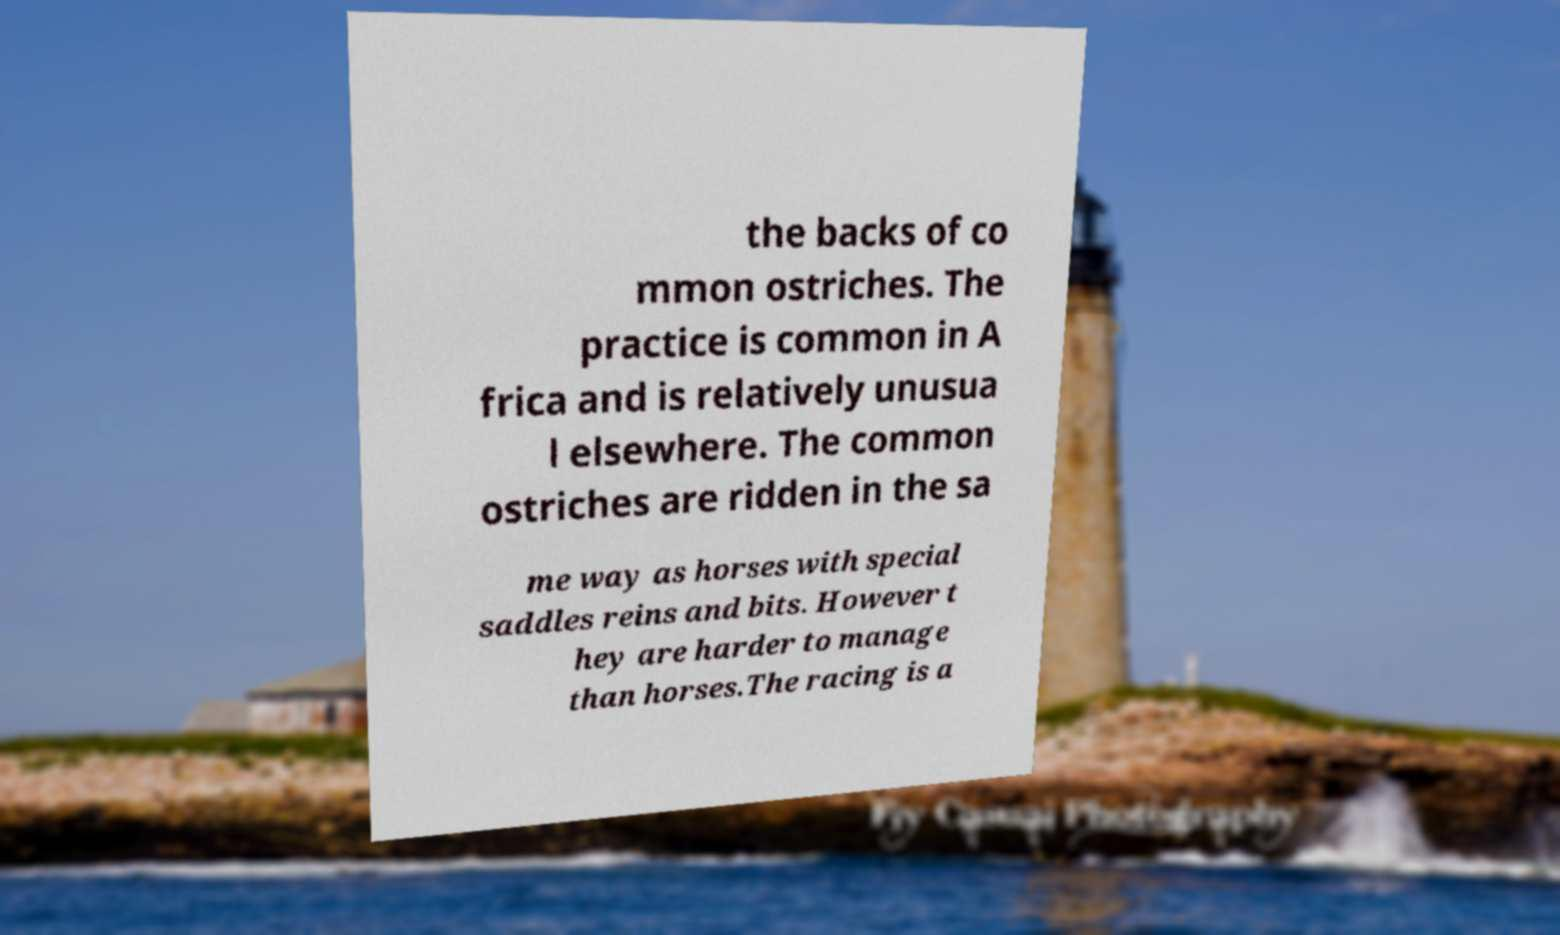What messages or text are displayed in this image? I need them in a readable, typed format. the backs of co mmon ostriches. The practice is common in A frica and is relatively unusua l elsewhere. The common ostriches are ridden in the sa me way as horses with special saddles reins and bits. However t hey are harder to manage than horses.The racing is a 